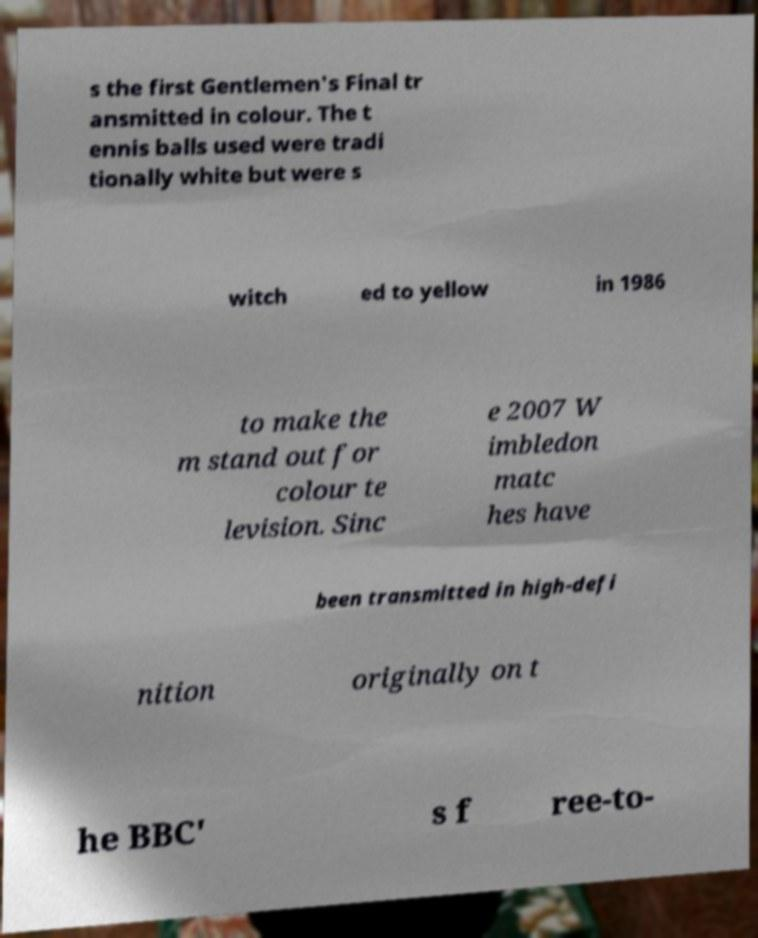Can you accurately transcribe the text from the provided image for me? s the first Gentlemen's Final tr ansmitted in colour. The t ennis balls used were tradi tionally white but were s witch ed to yellow in 1986 to make the m stand out for colour te levision. Sinc e 2007 W imbledon matc hes have been transmitted in high-defi nition originally on t he BBC' s f ree-to- 